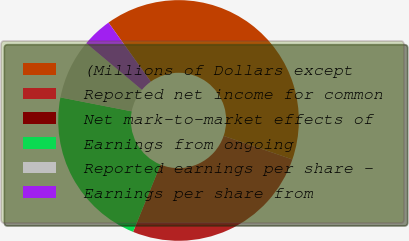Convert chart to OTSL. <chart><loc_0><loc_0><loc_500><loc_500><pie_chart><fcel>(Millions of Dollars except<fcel>Reported net income for common<fcel>Net mark-to-market effects of<fcel>Earnings from ongoing<fcel>Reported earnings per share -<fcel>Earnings per share from<nl><fcel>40.13%<fcel>25.92%<fcel>0.0%<fcel>21.9%<fcel>8.03%<fcel>4.02%<nl></chart> 